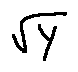Convert formula to latex. <formula><loc_0><loc_0><loc_500><loc_500>\sqrt { Y }</formula> 